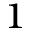<formula> <loc_0><loc_0><loc_500><loc_500>^ { 1 }</formula> 